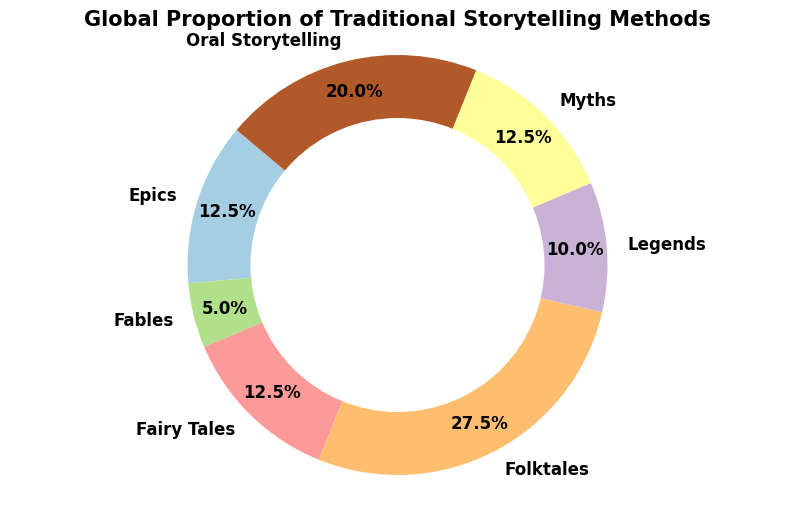What is the most common traditional storytelling method globally? To determine the most common method, we look for the segment with the largest proportion. The 'Fairy Tales' section occupies 25% of the total pie chart.
Answer: Fairy Tales How much larger is the proportion of 'Fairy Tales' compared to 'Fables'? 'Fairy Tales' make up 25% while 'Fables' make up 10%. The difference can be calculated as 25% - 10% = 15%.
Answer: 15% Which region contributes to 'Oral Storytelling' and what is its proportion? According to the data, 'Oral Storytelling' is only present in Africa and South America. The proportions are 25% from Africa and 15% from South America, giving a combined proportion of 40%.
Answer: Africa and South America, 40% What is the total proportion of storytelling methods originating from Europe? The types from Europe are 'Legends' at 20%, 'Fairy Tales' at 25%, and 'Epics' at 10%. Summing these up gives 20% + 25% + 10% = 55%.
Answer: 55% If 'Folktales' were divided evenly among Africa, Asia, North America, and Oceania, what proportion would each region contribute? 'Folktales' account for 20% + 15% + 10% + 10% = 55%. Dividing this evenly among 4 regions, each region would then contribute 55% / 4 = 13.75%.
Answer: 13.75% Which storytelling method has the smallest proportion, and what is that proportion? The storytelling methods with the smallest proportion each have 5%, which includes 'Myths' in North America, Oceania, and South America.
Answer: 5% How do Epics in Asia compare to Epics in Europe in their combined proportion? Epics comprise 15% in Asia and 10% in Europe. Their combined proportion is 15% + 10% = 25%.
Answer: 25% What’s the proportion difference between the total for 'Oral Storytelling' and 'Myths'? Combining the regions, 'Oral Storytelling' is 40% and 'Myths' are 10% + 5% + 5% = 20%. The difference is 40% - 20% = 20%.
Answer: 20% If we combine the proportions of all types in Asia, what’s the total? For Asia, 'Folktales' are 20%, 'Epics' are 15%, and 'Fables' are 10%, giving a total of 20% + 15% + 10% = 45%.
Answer: 45% Are 'Legends' more popular than 'Folktales' around the world? 'Legends' have a global proportion of 20%, and 'Folktales' add up to 0.15+0.2+0.1+0.1 = 0.55 (or 55%). Comparing 20% and 55%, 'Folktales' are more popular.
Answer: No 